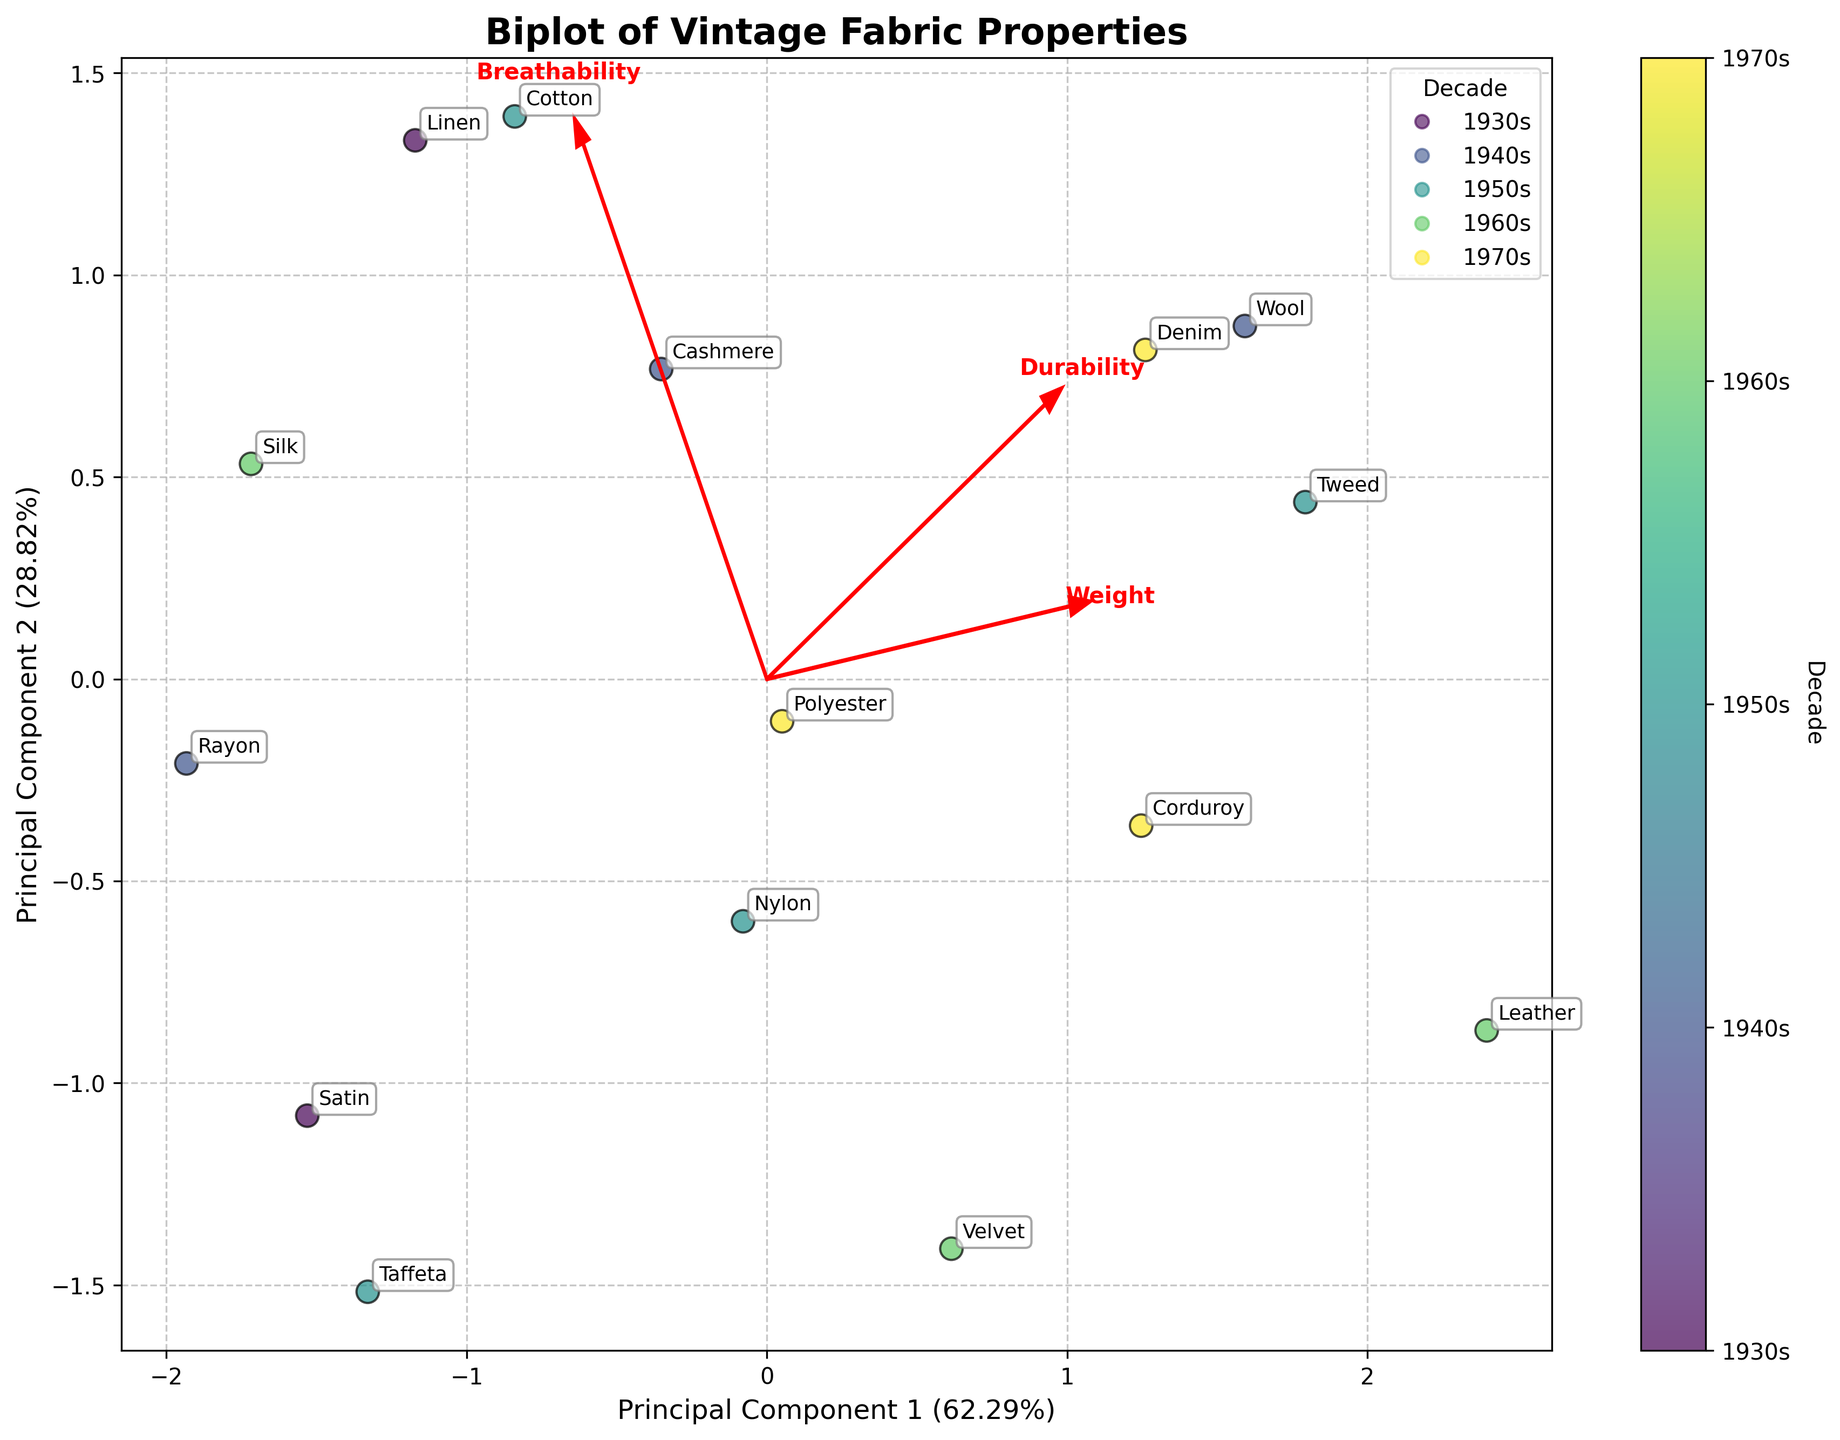What is the title of the plot? The title is typically placed at the top of the figure. In this case, it reads "Biplot of Vintage Fabric Properties."
Answer: Biplot of Vintage Fabric Properties How many components were used in the PCA? The axes labels indicate "Principal Component 1" and "Principal Component 2," meaning two components were used in the PCA.
Answer: Two Which decade has the fabric with the highest durability according to the plot? Durability is one of the principal components. By checking the plot for higher durability scores, and cross-referencing the decade color code, we see that fabrics like Wool (1940s) and Denim (1970s) have high durability. However, the highest durability is denoted by Wool in the 1940s.
Answer: 1940s Which fabrics are located farthest to the right on Principal Component 1? Principal Component 1 is the x-axis. The fabrics located farthest to the right on this axis are Rayon and Tweed.
Answer: Rayon and Tweed Which feature vector is aligned closest to the vertical axis (Principal Component 2)? Feature vectors are represented as arrows. The arrow for Breathability is closely aligned with the vertical axis (Principal Component 2).
Answer: Breathability Which decade is represented by a light green color in the scatter plot? The color bar indicates that the light green corresponds to the 1960s.
Answer: 1960s Which two fabrics appear closest to each other in the biplot? By visually inspecting the distances between annotated fabric points, Rayon and Silk appear closest to each other.
Answer: Rayon and Silk How does the Weight feature influence Principal Component 1 and Principal Component 2? The direction and length of the Weight vector indicate its influence. The Weight arrow points positively on both the Principal Component 1 (x-axis) and Principal Component 2 (y-axis), suggesting it has a positive influence on both components.
Answer: Positive influence on both Which fabric from the 1930s is shown in the plot, and what is its approximate location? By checking the annotations and decades, the 1930s have Linen and Satin. Their respective locations are based on Principal Components: Linen is negative on PC1 and positive on PC2, and Satin is a little negative on PC1 and negative on PC2.
Answer: Linen and Satin Which fabrics from the 1970s show above-average weight? Above-average weight is inferred by checking the position of the corresponding data points relative to the Weight vector. Fabrics from the 1970s include Corduroy, Polyester, and Denim. Among these, Corduroy and Denim show higher weights as per their position in the biplot.
Answer: Corduroy and Denim 